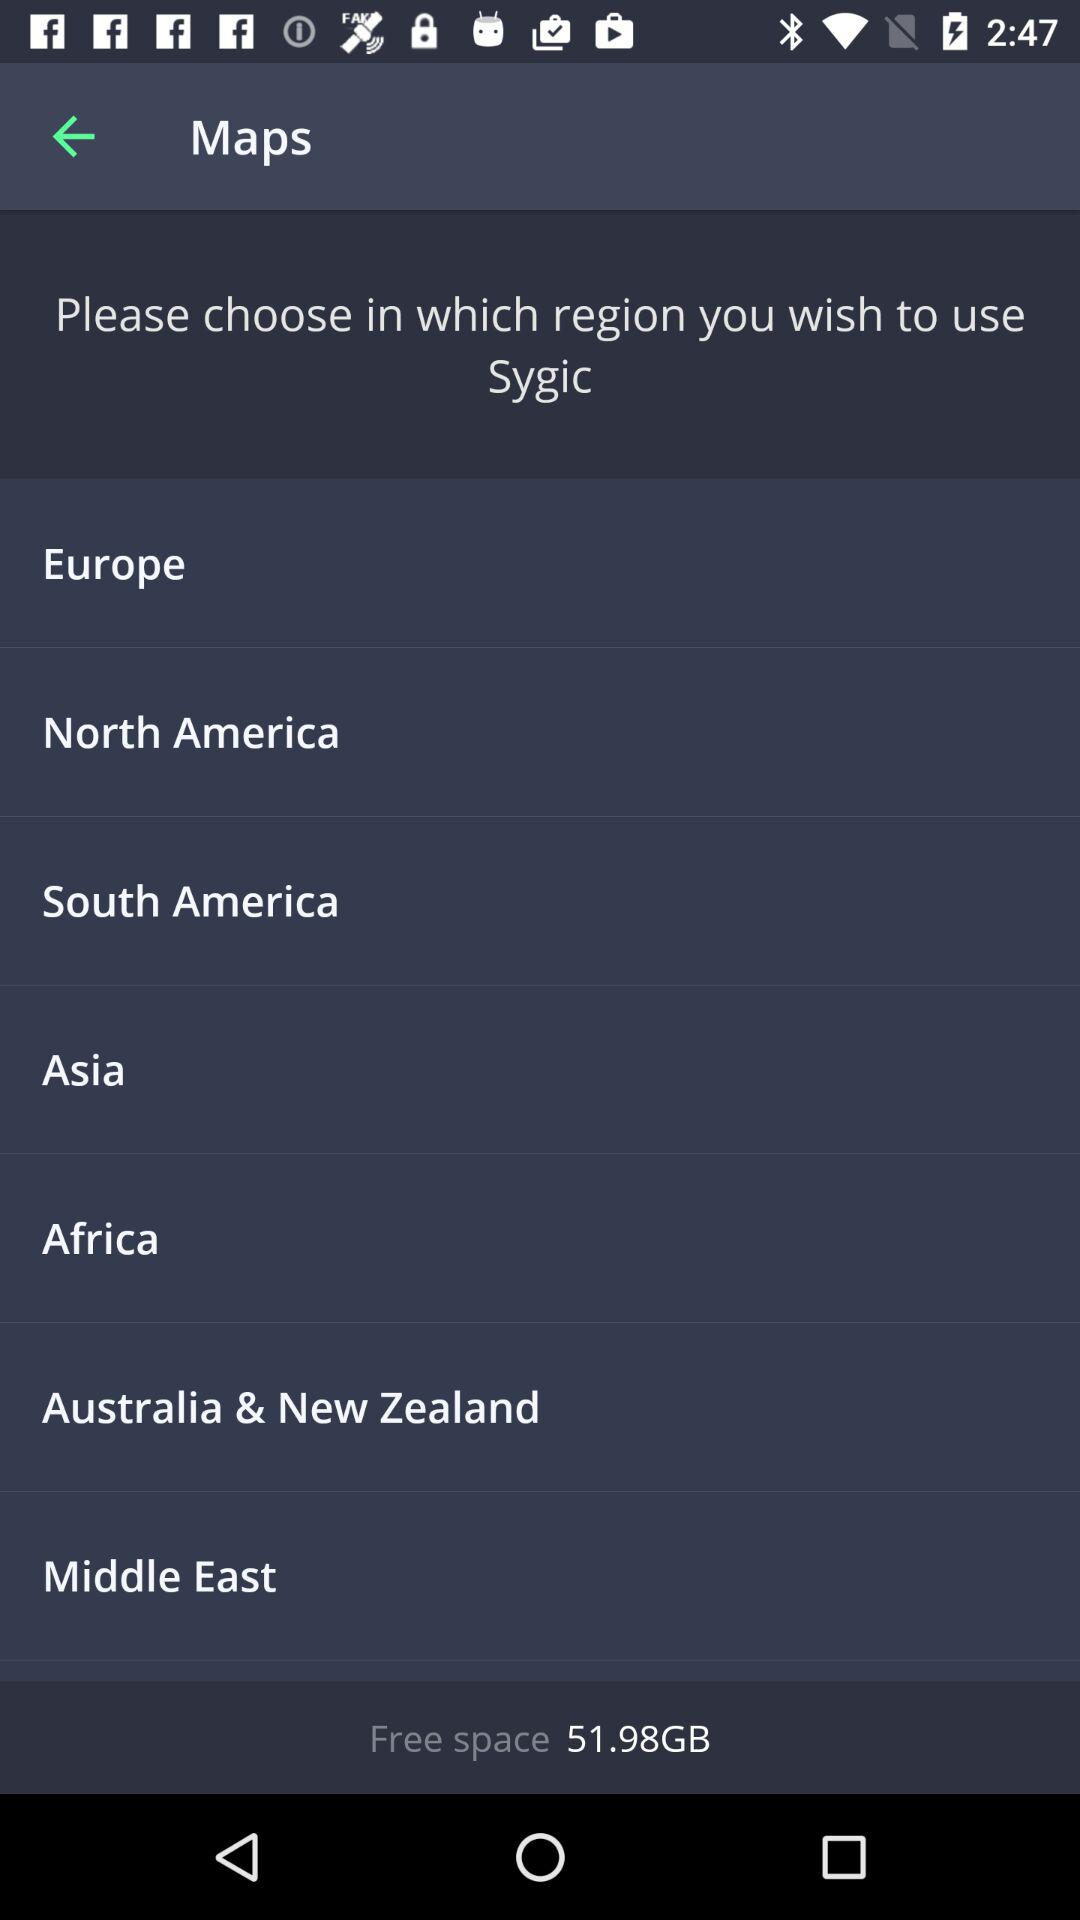How much free space is available on the device? The device currently has 51.98GB of free space, which is ample for storing a vast array of apps, photos, and other content. 